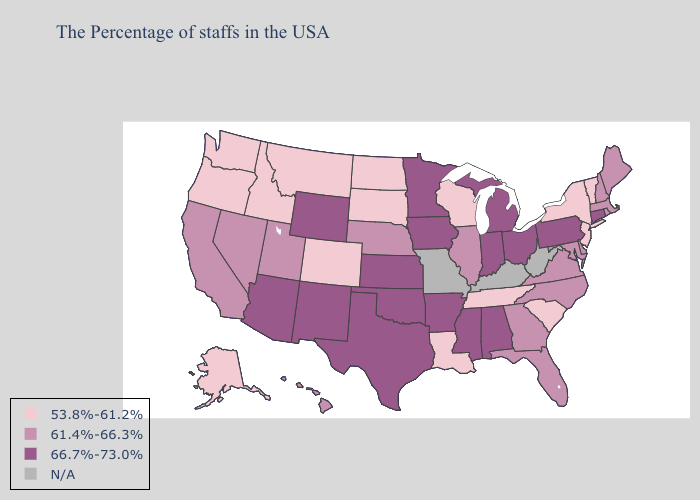What is the highest value in the Northeast ?
Keep it brief. 66.7%-73.0%. Name the states that have a value in the range N/A?
Keep it brief. West Virginia, Kentucky, Missouri. Among the states that border Tennessee , does Mississippi have the highest value?
Short answer required. Yes. What is the value of Florida?
Short answer required. 61.4%-66.3%. Which states hav the highest value in the South?
Answer briefly. Alabama, Mississippi, Arkansas, Oklahoma, Texas. Name the states that have a value in the range 66.7%-73.0%?
Answer briefly. Connecticut, Pennsylvania, Ohio, Michigan, Indiana, Alabama, Mississippi, Arkansas, Minnesota, Iowa, Kansas, Oklahoma, Texas, Wyoming, New Mexico, Arizona. What is the value of Arizona?
Write a very short answer. 66.7%-73.0%. Which states have the lowest value in the Northeast?
Quick response, please. Vermont, New York, New Jersey. Does New Hampshire have the lowest value in the USA?
Be succinct. No. Does the map have missing data?
Concise answer only. Yes. What is the lowest value in the West?
Quick response, please. 53.8%-61.2%. Which states have the lowest value in the Northeast?
Give a very brief answer. Vermont, New York, New Jersey. What is the lowest value in states that border New York?
Be succinct. 53.8%-61.2%. Does Maine have the highest value in the USA?
Give a very brief answer. No. Among the states that border Vermont , which have the highest value?
Write a very short answer. Massachusetts, New Hampshire. 